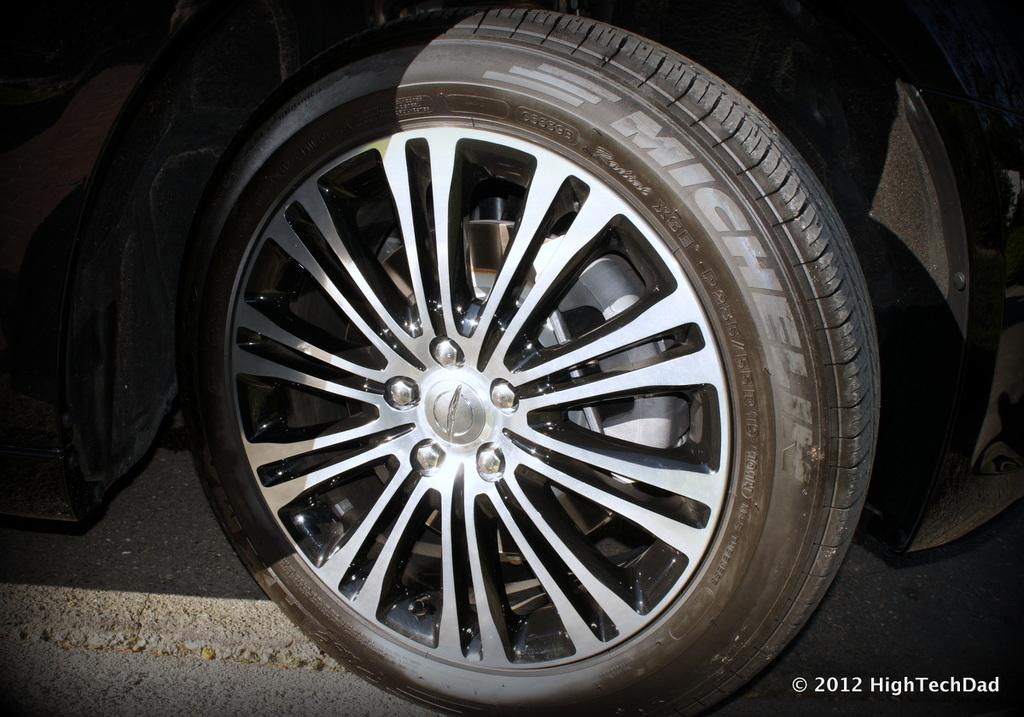What is the main subject of the image? The main subject of the image is a vehicle on the road. Can you describe the text on the right side of the image? Unfortunately, the provided facts do not give any information about the text on the right side of the image. How many chains are attached to the vehicle in the image? There is no mention of chains in the provided facts, so we cannot determine if any chains are attached to the vehicle in the image. 